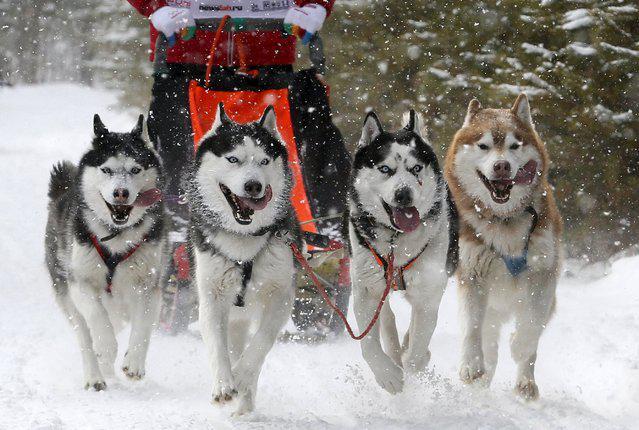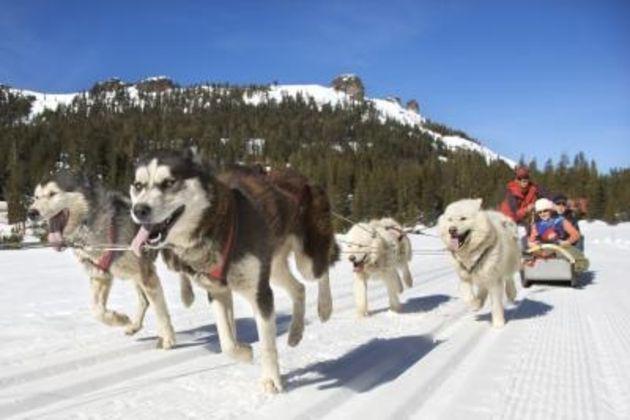The first image is the image on the left, the second image is the image on the right. Examine the images to the left and right. Is the description "Non-snow-covered evergreens and a flat horizon are behind one of the sled dog teams." accurate? Answer yes or no. No. The first image is the image on the left, the second image is the image on the right. For the images shown, is this caption "The left image contains exactly four sled dogs." true? Answer yes or no. Yes. 